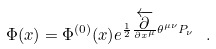<formula> <loc_0><loc_0><loc_500><loc_500>\Phi ( x ) = \Phi ^ { ( 0 ) } ( x ) e ^ { \frac { 1 } { 2 } \frac { \overleftarrow { \partial } } { \partial x ^ { \mu } } \theta ^ { \mu \nu } P _ { \nu } } \ .</formula> 